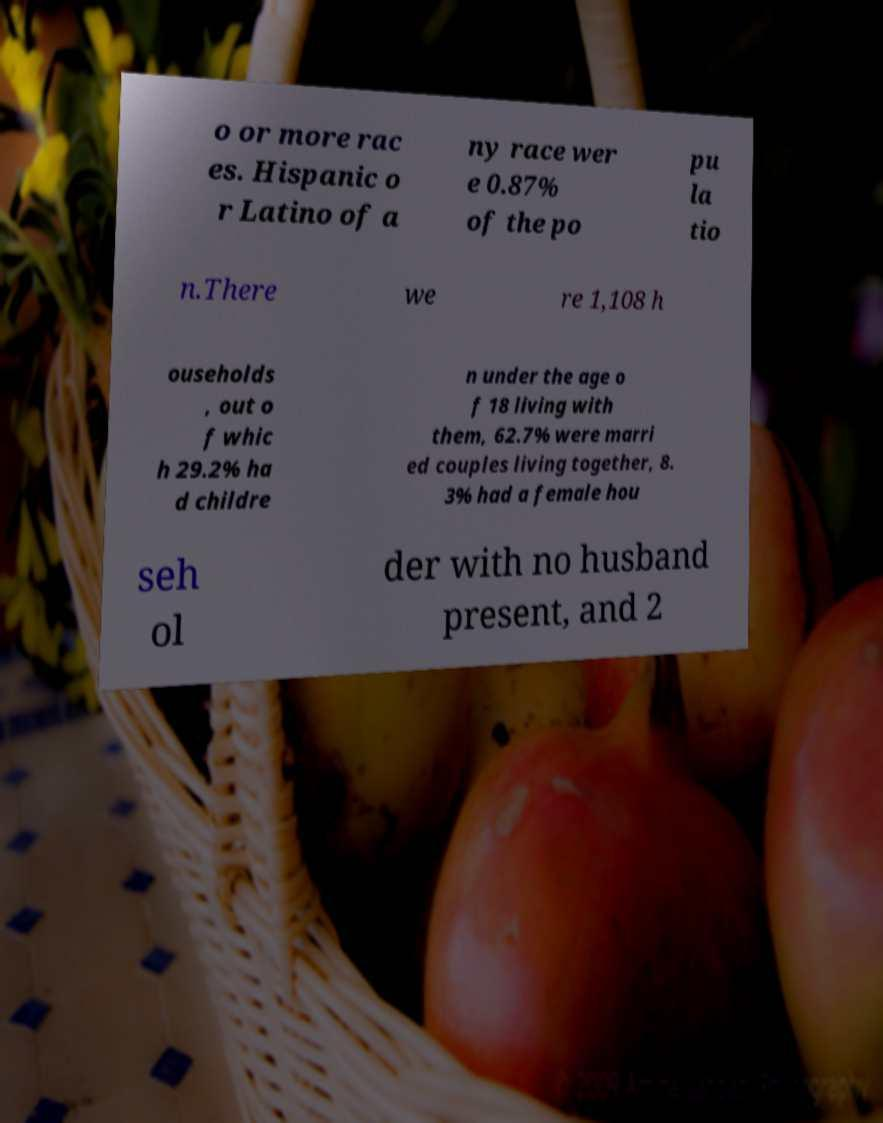There's text embedded in this image that I need extracted. Can you transcribe it verbatim? o or more rac es. Hispanic o r Latino of a ny race wer e 0.87% of the po pu la tio n.There we re 1,108 h ouseholds , out o f whic h 29.2% ha d childre n under the age o f 18 living with them, 62.7% were marri ed couples living together, 8. 3% had a female hou seh ol der with no husband present, and 2 